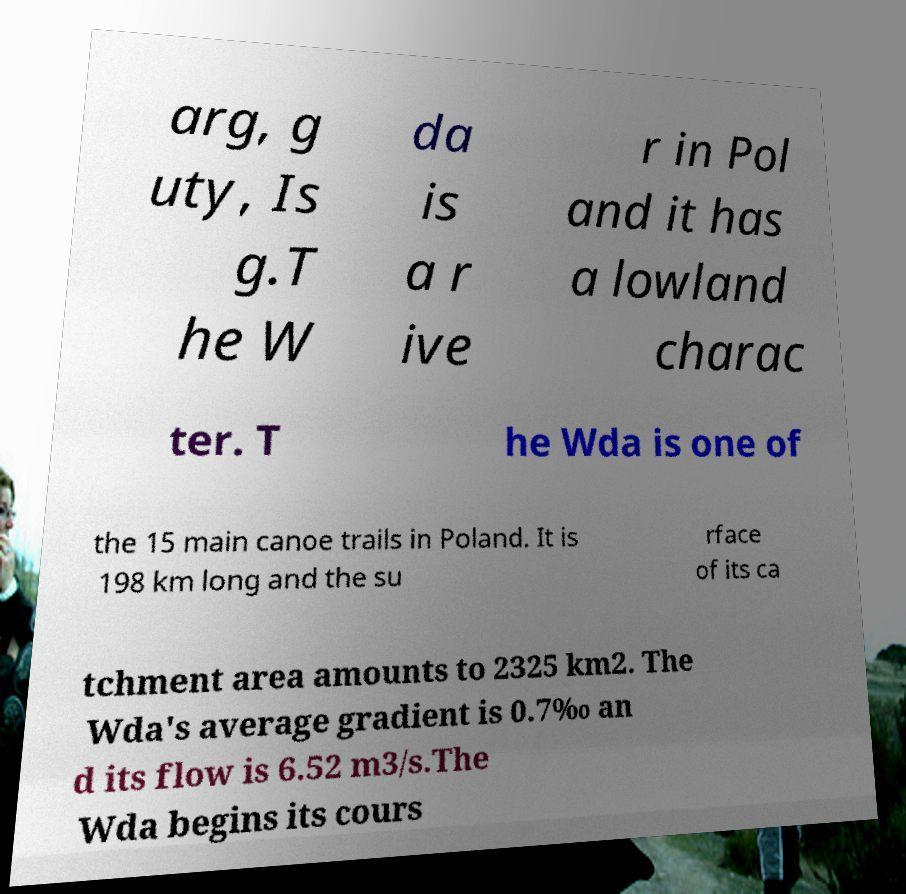What messages or text are displayed in this image? I need them in a readable, typed format. arg, g uty, Is g.T he W da is a r ive r in Pol and it has a lowland charac ter. T he Wda is one of the 15 main canoe trails in Poland. It is 198 km long and the su rface of its ca tchment area amounts to 2325 km2. The Wda's average gradient is 0.7‰ an d its flow is 6.52 m3/s.The Wda begins its cours 